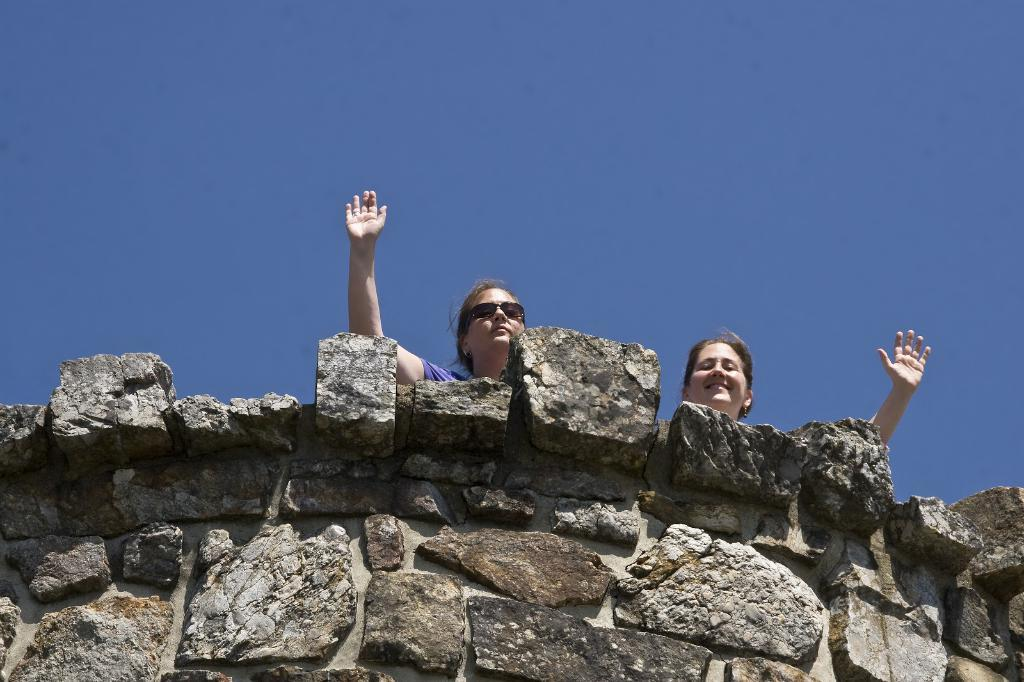What is located in the foreground of the image? There is a stone wall in the foreground of the image. What is happening in the center of the image? There are two women in the center of the image, and they are raising their hands. What is the condition of the sky in the image? The sky is clear in the image. What is the weather like in the image? It is sunny in the image. How many thumbs can be seen on the women's hands in the image? There is no specific mention of thumbs in the image, so it is not possible to determine the number of thumbs visible. What type of health advice can be seen on the women's fingers in the image? There is no health advice or mention of fingers in the image. 